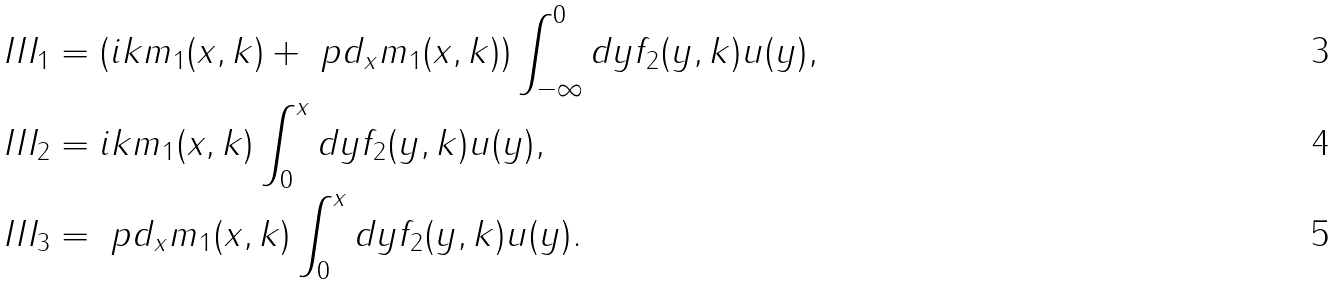<formula> <loc_0><loc_0><loc_500><loc_500>& I I I _ { 1 } = ( i k m _ { 1 } ( x , k ) + \ p d _ { x } m _ { 1 } ( x , k ) ) \int _ { - \infty } ^ { 0 } d y f _ { 2 } ( y , k ) u ( y ) , \\ & I I I _ { 2 } = i k m _ { 1 } ( x , k ) \int _ { 0 } ^ { x } d y f _ { 2 } ( y , k ) u ( y ) , \\ & I I I _ { 3 } = \ p d _ { x } m _ { 1 } ( x , k ) \int _ { 0 } ^ { x } d y f _ { 2 } ( y , k ) u ( y ) .</formula> 